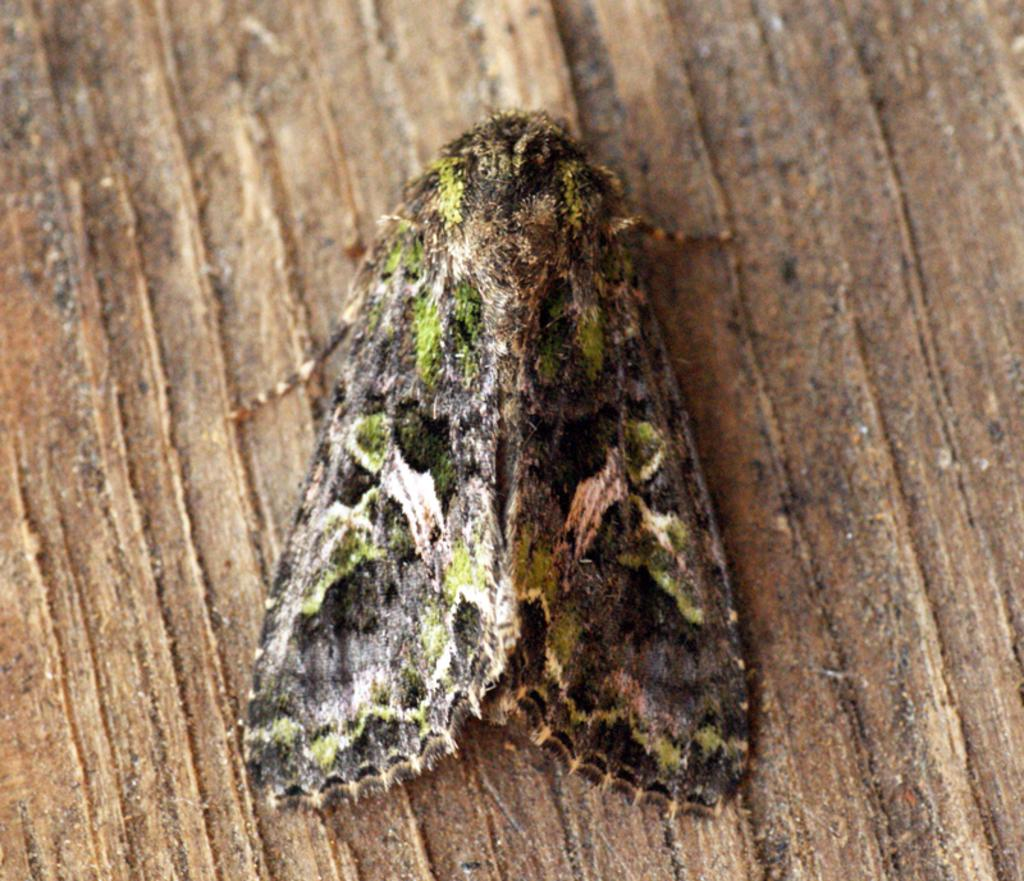What is present on the wooden surface in the image? There is an insect on the wooden surface in the image. Can you describe the wooden surface in the image? The wooden surface is the background on which the insect is present. How many visitors are present in the image? There are no visitors mentioned or visible in the image; only an insect on a wooden surface is present. 